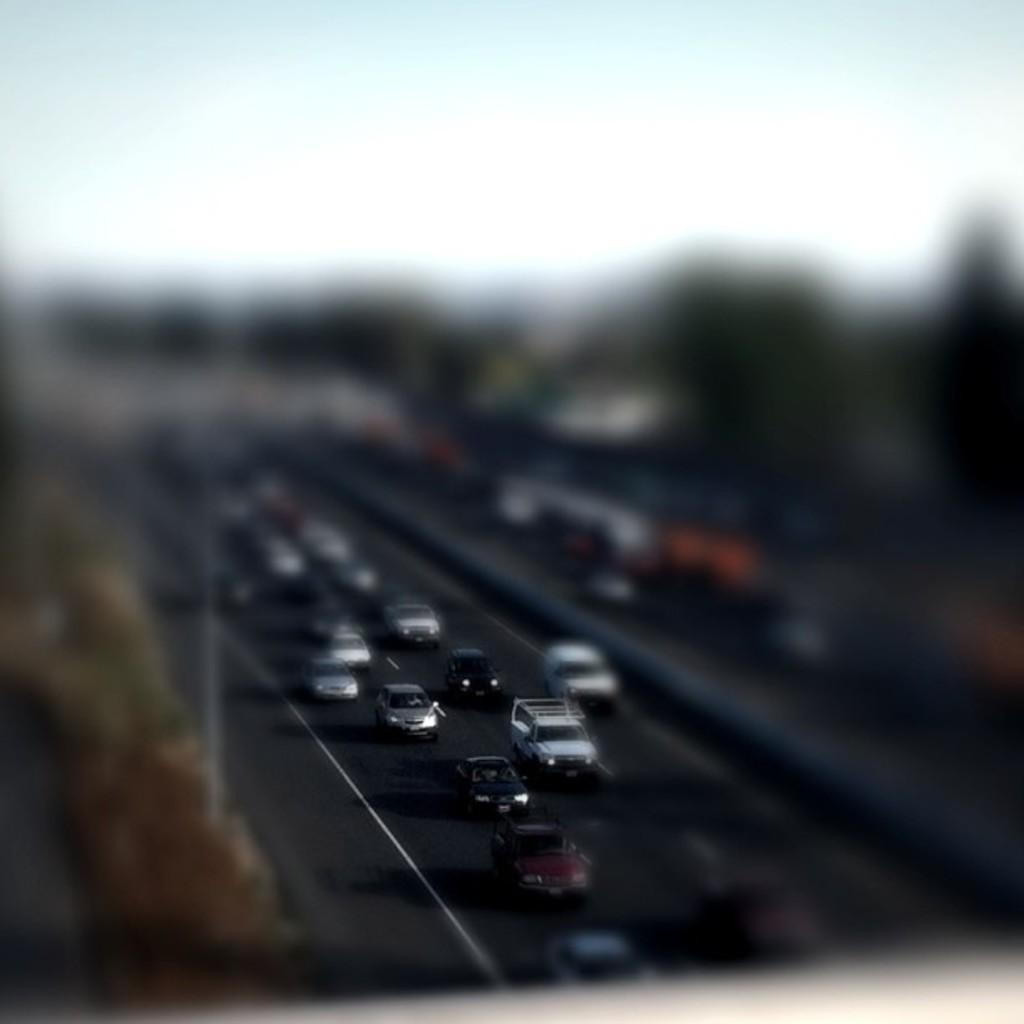What is happening in the image? There are vehicles moving on a road in the image. Can you describe the vehicles in the image? Unfortunately, the remaining part of the image is blurred, so it is not possible to describe the vehicles in detail. Where are the lizards hiding in the image? There are no lizards present in the image. What type of jam is being spread on the secretary's toast in the image? There is no jam or secretary present in the image. 